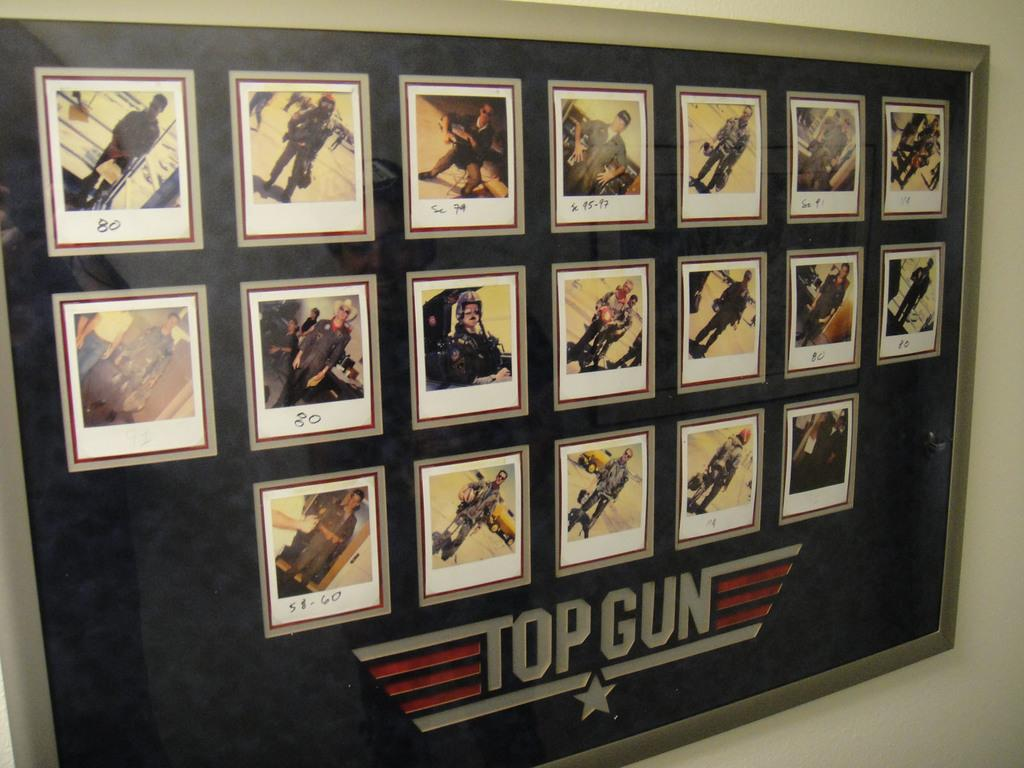<image>
Offer a succinct explanation of the picture presented. A bulletin board labled Top Gun shows pictures of soldiers. 